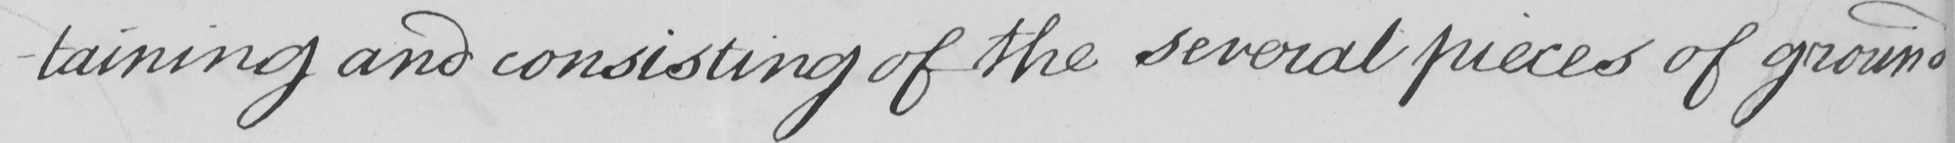Can you tell me what this handwritten text says? - taining and consisting of the several pieces of ground 